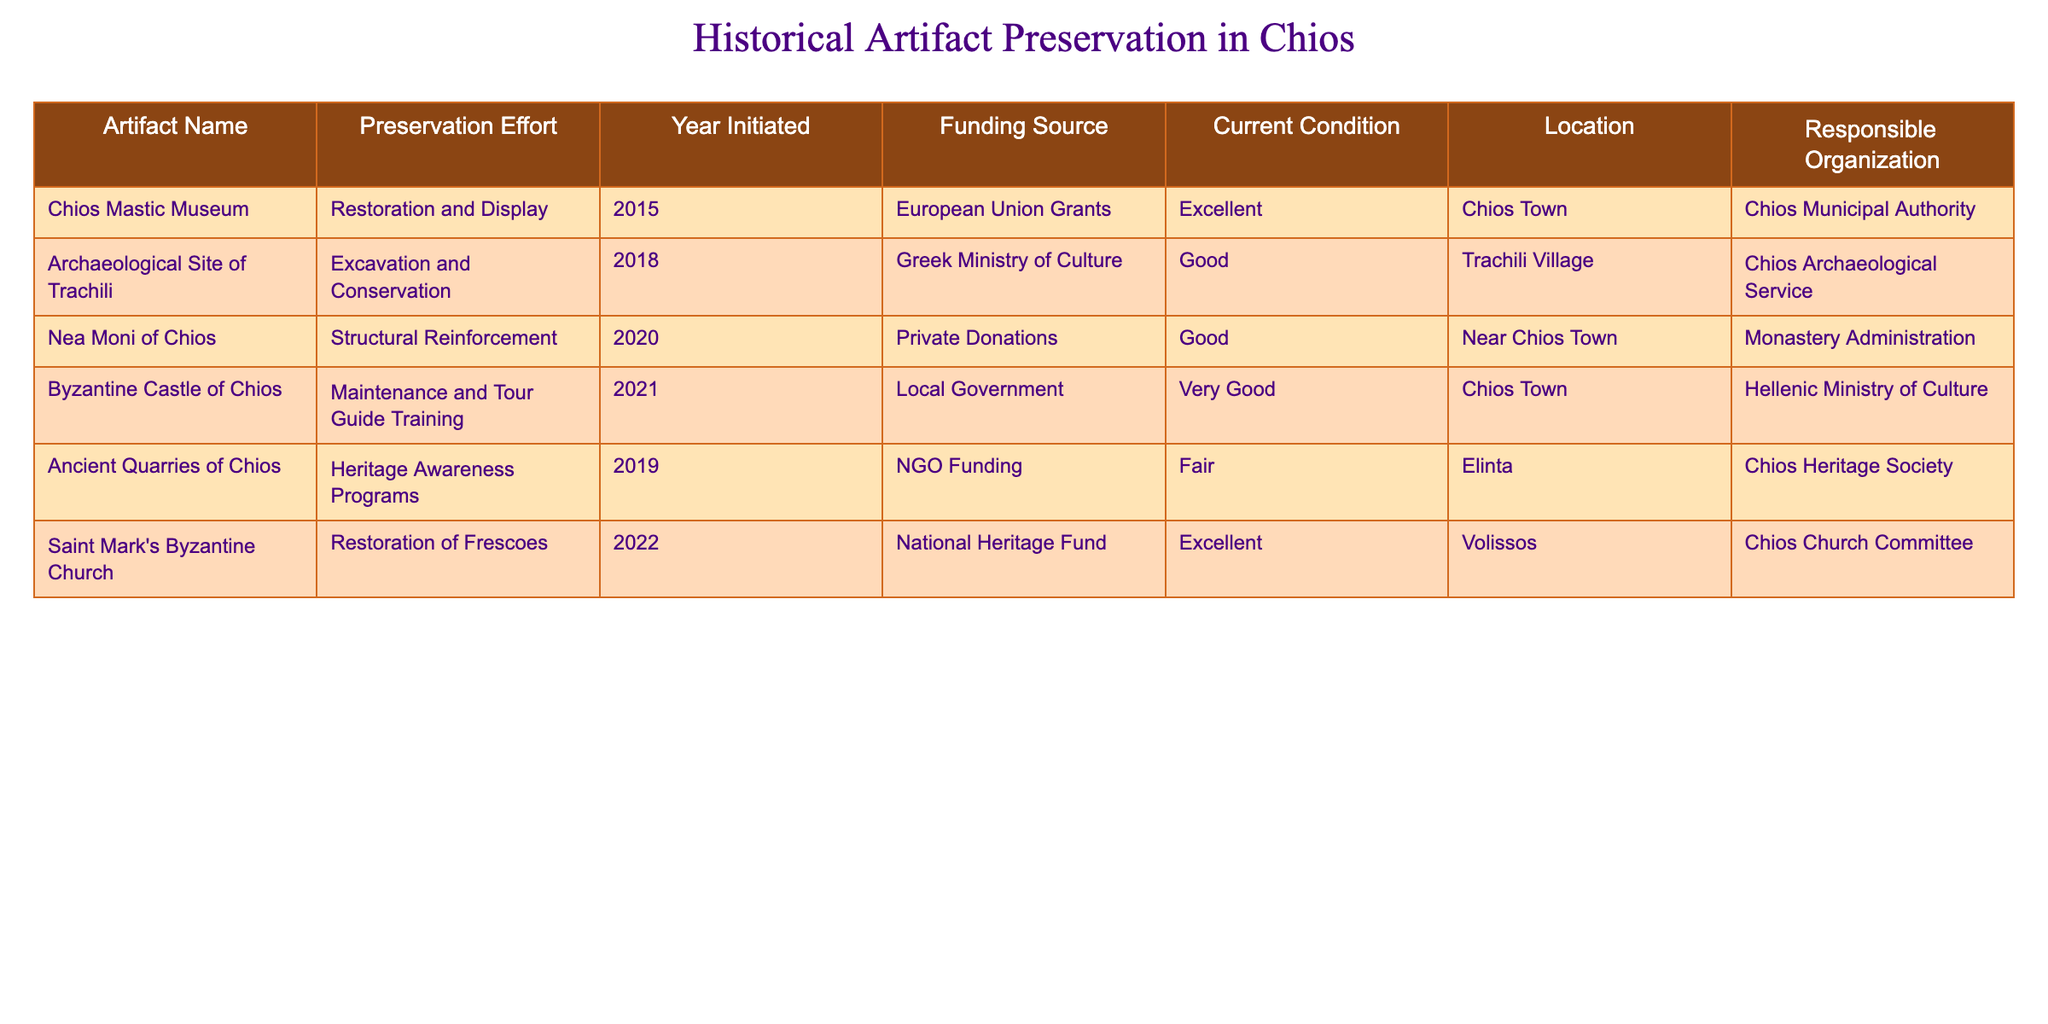What is the current condition of the Chios Mastic Museum? The current condition of the Chios Mastic Museum is mentioned in the table under the "Current Condition" column. According to the table, it is in "Excellent" condition.
Answer: Excellent Which artifact had the lowest funding source listed? To determine the lowest funding source, we need to assess the different funding sources provided in the table. "Private Donations" is derived from only the Nea Moni of Chios, and it can be considered less institutional than the European Union Grants or the National Heritage Fund. Thus, it is seen as less formal funding compared to others like the European Union Grants and Greek Ministry of Culture.
Answer: Private Donations How many artifacts have been preserved in "Excellent" condition? In the table, we count the entries under "Current Condition" to identify how many are labeled "Excellent." There are three artifacts with this status: Chios Mastic Museum, Saint Mark's Byzantine Church, and the others do not match this condition. Hence, the total is 2.
Answer: 2 Is it true that the Byzantine Castle of Chios is located in Chios Town? The table specifies the location of the Byzantine Castle of Chios under the "Location" column. It states that the castle is in "Chios Town," confirming the statement as true.
Answer: Yes Which preservation effort started the earliest and what year was it initiated? To find the earliest preservation effort, we compare the "Year Initiated" for each artifact listed in the table. The Chios Mastic Museum began its restoration and display in 2015, which is the earliest mentioned. Therefore, the earliest preservation effort is for the Chios Mastic Museum, initiated in 2015.
Answer: Chios Mastic Museum, 2015 